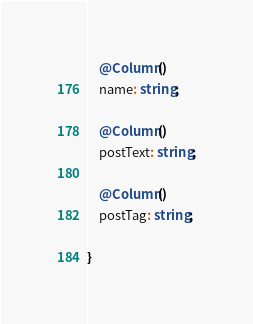<code> <loc_0><loc_0><loc_500><loc_500><_TypeScript_>
    @Column()
    name: string;

    @Column()
    postText: string;

    @Column()
    postTag: string;

}</code> 